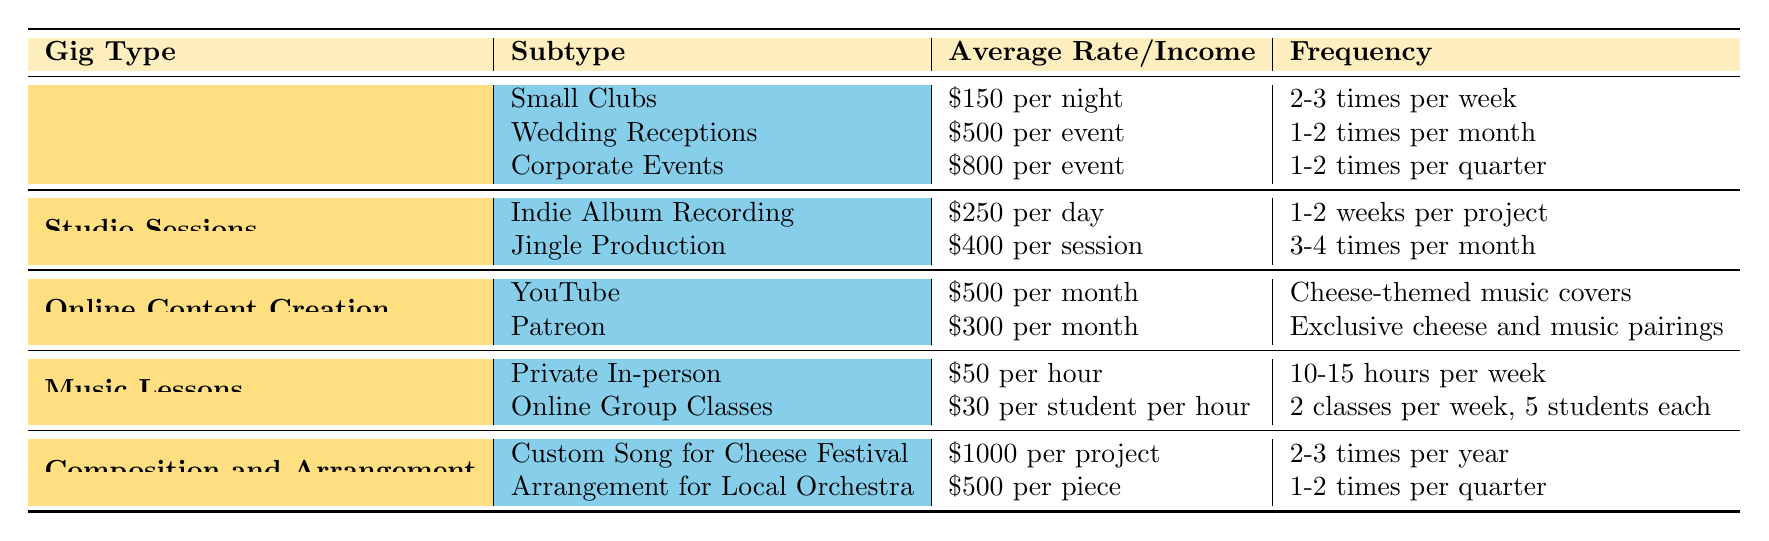What is the average rate for performing at wedding receptions? The table states that the average rate for wedding receptions is \$500 per event.
Answer: \$500 per event How many times a week does a freelancer typically perform at small clubs? According to the table, freelancers perform at small clubs 2-3 times per week.
Answer: 2-3 times per week What is the highest average rate for a gig type in this table? The table lists Corporate Events at \$800 per event as the highest average rate.
Answer: \$800 per event How much can a musician expect to earn from YouTube in a month? The average income from YouTube, as per the table, is \$500 per month.
Answer: \$500 per month If a musician teaches 12 hours a week at the private in-person rate, what is the weekly income? The average rate for private in-person lessons is \$50 per hour; therefore, 12 hours would yield \$50 x 12 = \$600 per week.
Answer: \$600 per week How many times per year does a musician typically create a custom song for a cheese festival? The data indicates that a musician typically works on a custom song for a cheese festival 2-3 times per year.
Answer: 2-3 times per year Which gig type offers the lowest average rate? The lowest average rate can be found in the music lessons category, particularly for online group classes at \$30 per student per hour.
Answer: \$30 per student per hour What is the combined average monthly income from YouTube and Patreon? Adding the YouTube income of \$500 and the Patreon income of \$300 gives a total of \$500 + \$300 = \$800 per month.
Answer: \$800 per month Is it true that a musician can expect to earn more for an arrangement for a local orchestra than for a custom song for a cheese festival? Comparing the averages, a custom song for a cheese festival pays \$1000 per project while the arrangement pays \$500 per piece. Thus, it is false.
Answer: No If a musician performs at corporate events once per quarter, how many events do they perform in a year? There are 4 quarters in a year; thus, if they perform 1-2 times per quarter, that results in 1-2 events x 4, equaling 4-8 events per year.
Answer: 4-8 events per year What is the frequency of jingle production sessions per month? The average frequency for jingle production sessions is 3-4 times per month according to the table.
Answer: 3-4 times per month 